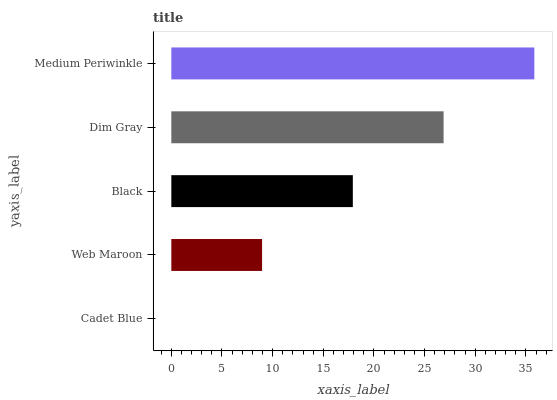Is Cadet Blue the minimum?
Answer yes or no. Yes. Is Medium Periwinkle the maximum?
Answer yes or no. Yes. Is Web Maroon the minimum?
Answer yes or no. No. Is Web Maroon the maximum?
Answer yes or no. No. Is Web Maroon greater than Cadet Blue?
Answer yes or no. Yes. Is Cadet Blue less than Web Maroon?
Answer yes or no. Yes. Is Cadet Blue greater than Web Maroon?
Answer yes or no. No. Is Web Maroon less than Cadet Blue?
Answer yes or no. No. Is Black the high median?
Answer yes or no. Yes. Is Black the low median?
Answer yes or no. Yes. Is Web Maroon the high median?
Answer yes or no. No. Is Dim Gray the low median?
Answer yes or no. No. 